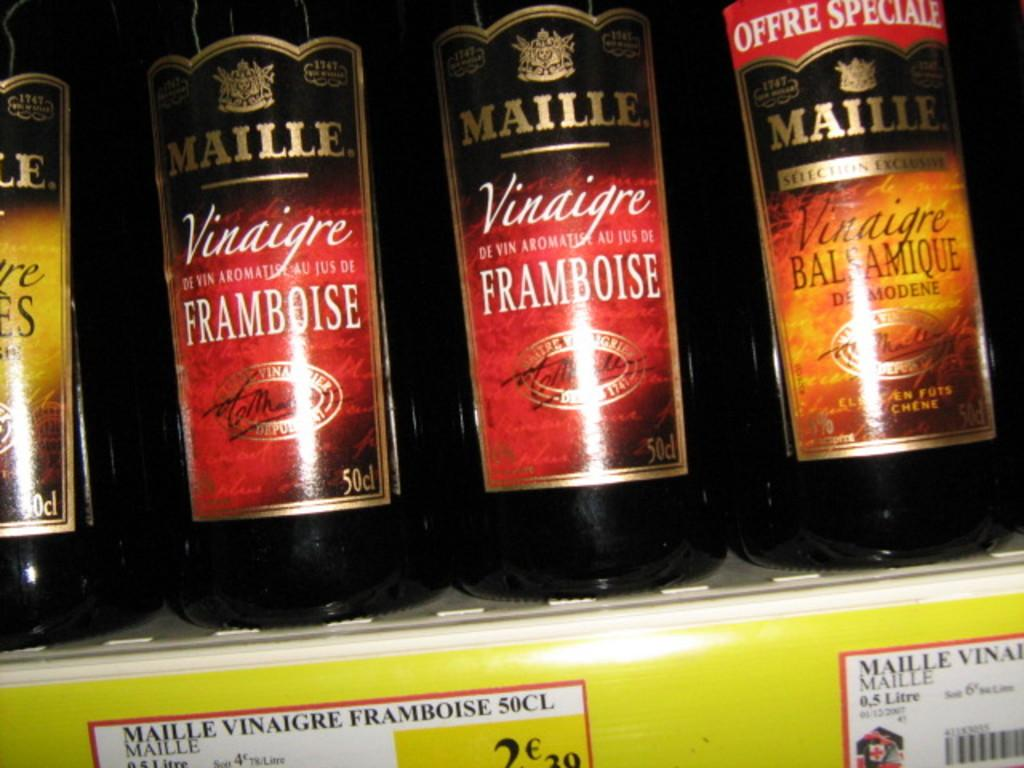Provide a one-sentence caption for the provided image. The brand of the vinegar in the store is Maille. 